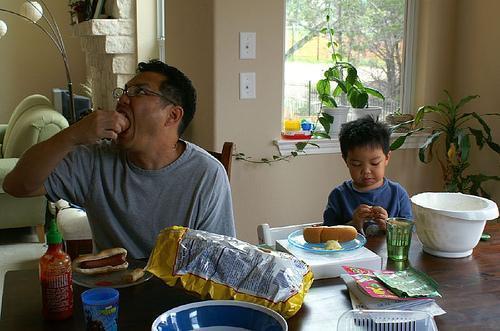How many people are in this picture?
Give a very brief answer. 2. How many people are there?
Give a very brief answer. 2. How many potted plants can you see?
Give a very brief answer. 2. How many bowls are there?
Give a very brief answer. 2. How many panel partitions on the blue umbrella have writing on them?
Give a very brief answer. 0. 